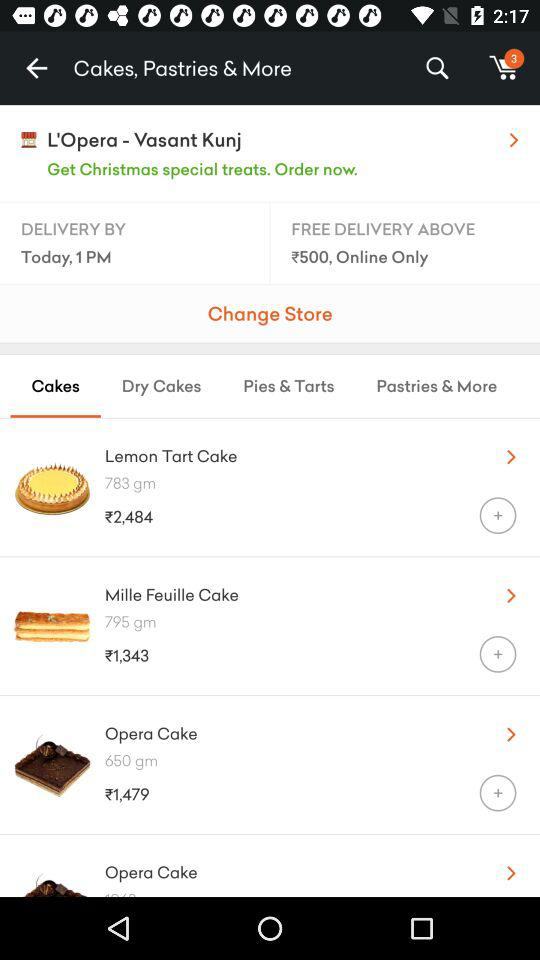How much does the "Mille Feuille Cake" weigh? The "Mille Feuille Cake" weighs 795 grams. 